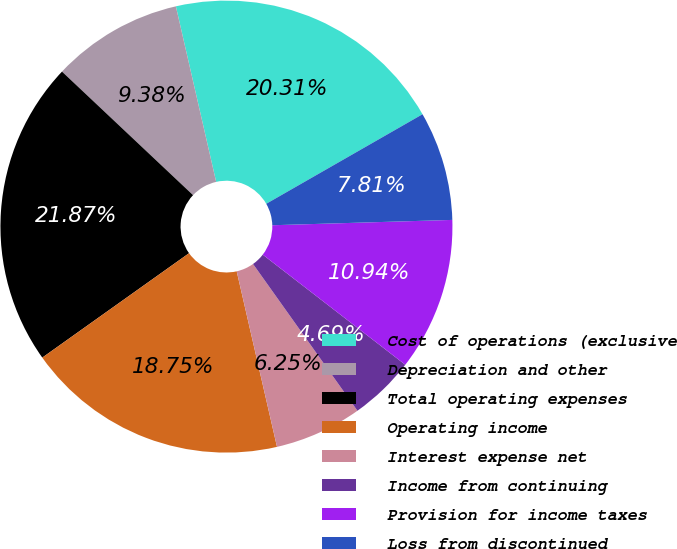Convert chart to OTSL. <chart><loc_0><loc_0><loc_500><loc_500><pie_chart><fcel>Cost of operations (exclusive<fcel>Depreciation and other<fcel>Total operating expenses<fcel>Operating income<fcel>Interest expense net<fcel>Income from continuing<fcel>Provision for income taxes<fcel>Loss from discontinued<nl><fcel>20.31%<fcel>9.38%<fcel>21.87%<fcel>18.75%<fcel>6.25%<fcel>4.69%<fcel>10.94%<fcel>7.81%<nl></chart> 